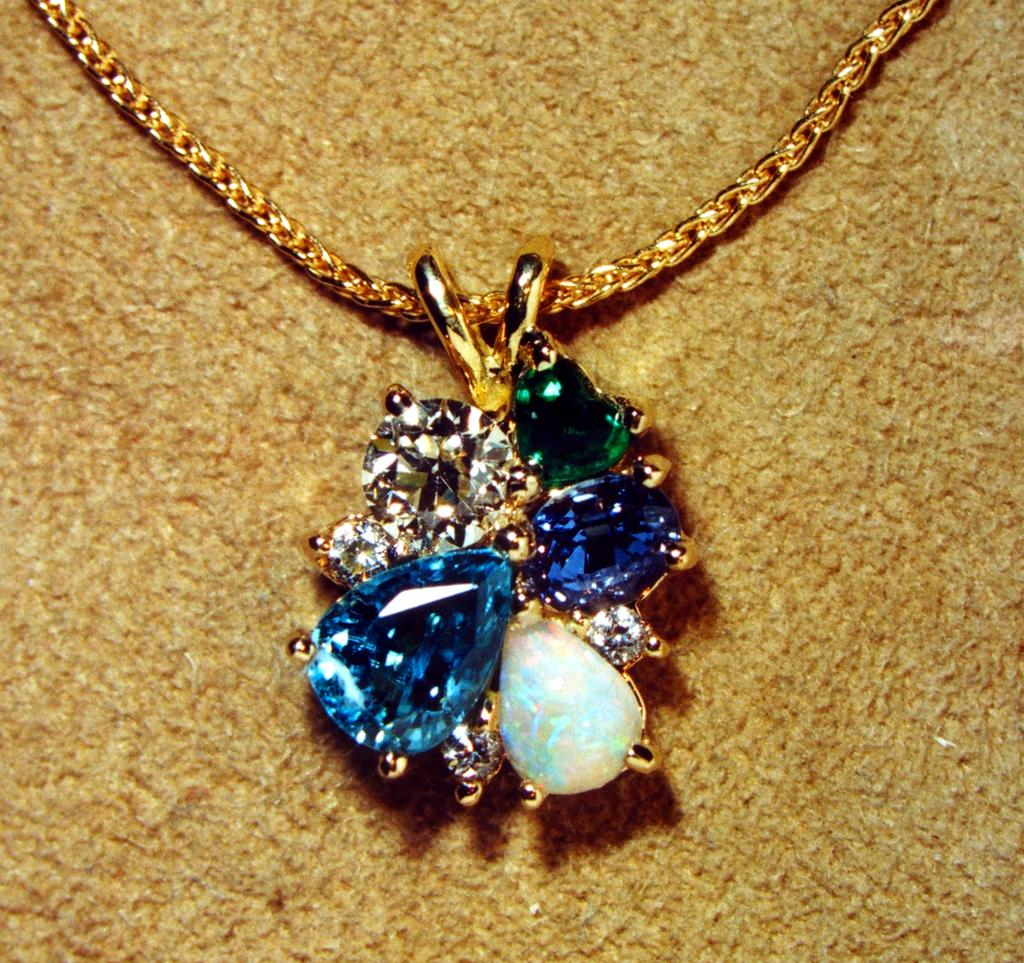What is the main object in the center of the image? There is a chain in the center of the image. What is attached to the chain? There is a pendant on the chain in the image. What type of grape can be seen hanging from the chain in the image? There is no grape present on the chain in the image. How does the pendant produce a whistling sound in the image? The pendant does not produce a whistling sound in the image, as there is no mention of a whistle or any sound-producing mechanism. 